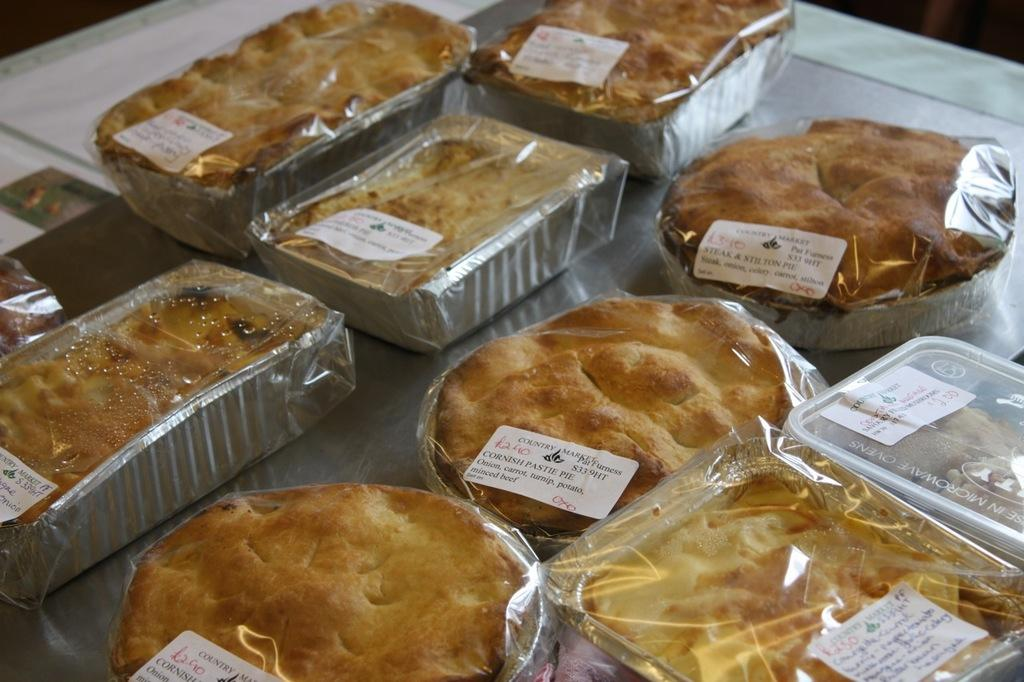What type of food can be seen in the image? The food in the image has a brown color. What is the color of the surface on which the food is placed? The food is on a white surface. What type of scent can be detected from the food in the image? The image does not provide any information about the scent of the food, so it cannot be determined from the image. 